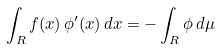Convert formula to latex. <formula><loc_0><loc_0><loc_500><loc_500>\int _ { R } f ( x ) \, \phi ^ { \prime } ( x ) \, d x = - \int _ { R } \phi \, d \mu</formula> 